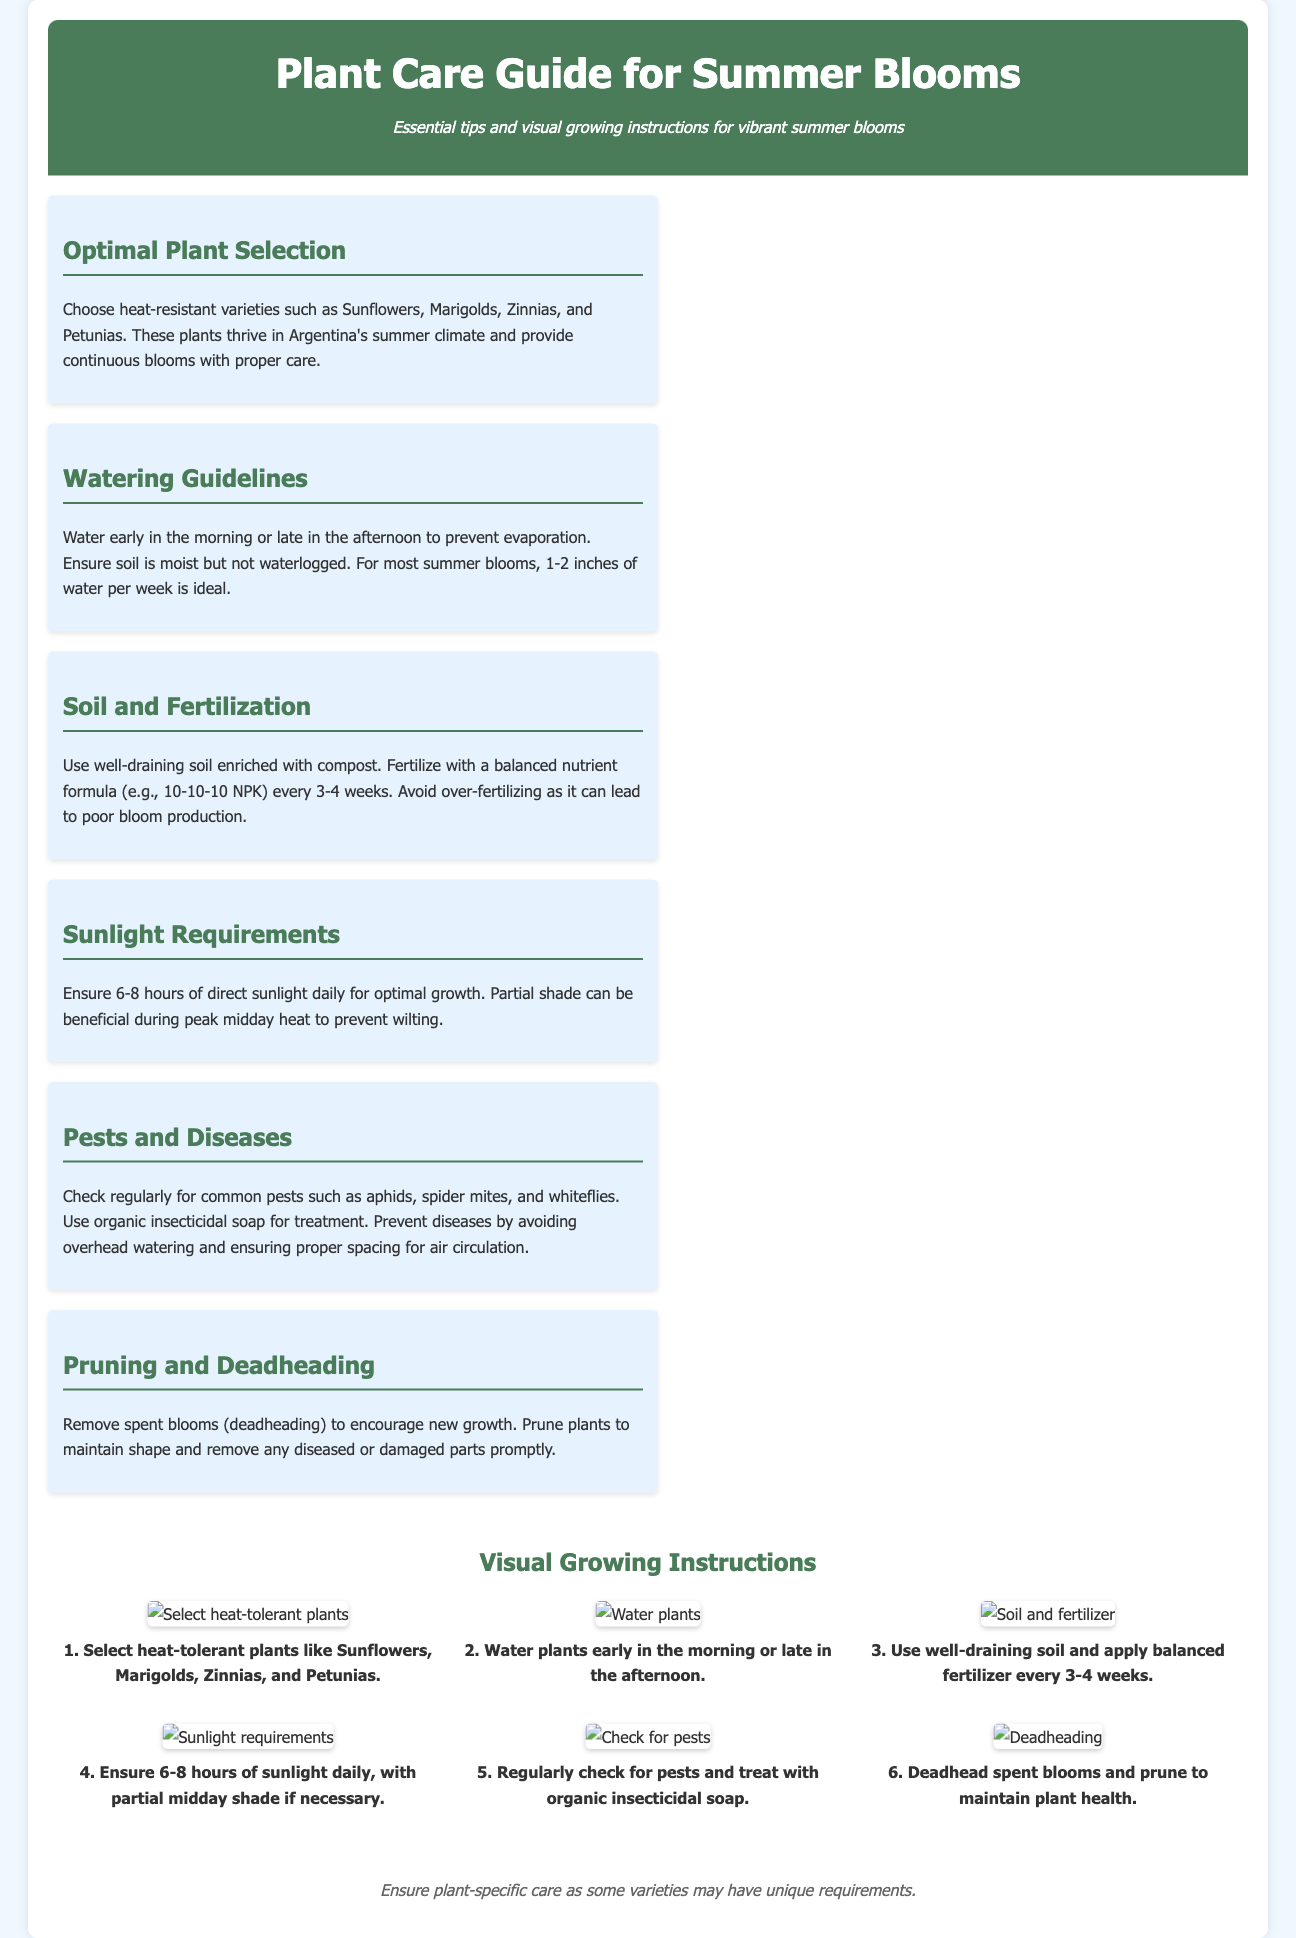What plants are recommended for summer blooms? The document specifies heat-resistant varieties such as Sunflowers, Marigolds, Zinnias, and Petunias as optimal selections for summer blooms.
Answer: Sunflowers, Marigolds, Zinnias, and Petunias How much water is ideal for summer blooms per week? The document indicates that for most summer blooms, 1-2 inches of water per week is ideal.
Answer: 1-2 inches What is the recommended frequency for fertilizing the plants? The guide states to fertilize with a balanced nutrient formula every 3-4 weeks.
Answer: Every 3-4 weeks How many hours of sunlight do summer blooms need daily? The document advises ensuring 6-8 hours of direct sunlight daily for optimal growth.
Answer: 6-8 hours Which pest treatment is suggested in the guide? The guide recommends using organic insecticidal soap for treatment against common pests.
Answer: Organic insecticidal soap What is the purpose of deadheading? The document explains that deadheading is performed to encourage new growth by removing spent blooms.
Answer: Encourage new growth What should be checked regularly for effective plant care? The guide mentions to check regularly for common pests such as aphids, spider mites, and whiteflies.
Answer: Common pests What action should be taken when pruning? The document advises to remove any diseased or damaged parts promptly when pruning.
Answer: Remove diseased or damaged parts What color is the header background in the document? The document describes the header background color as a shade of green, specifically #4a7c59.
Answer: Green 